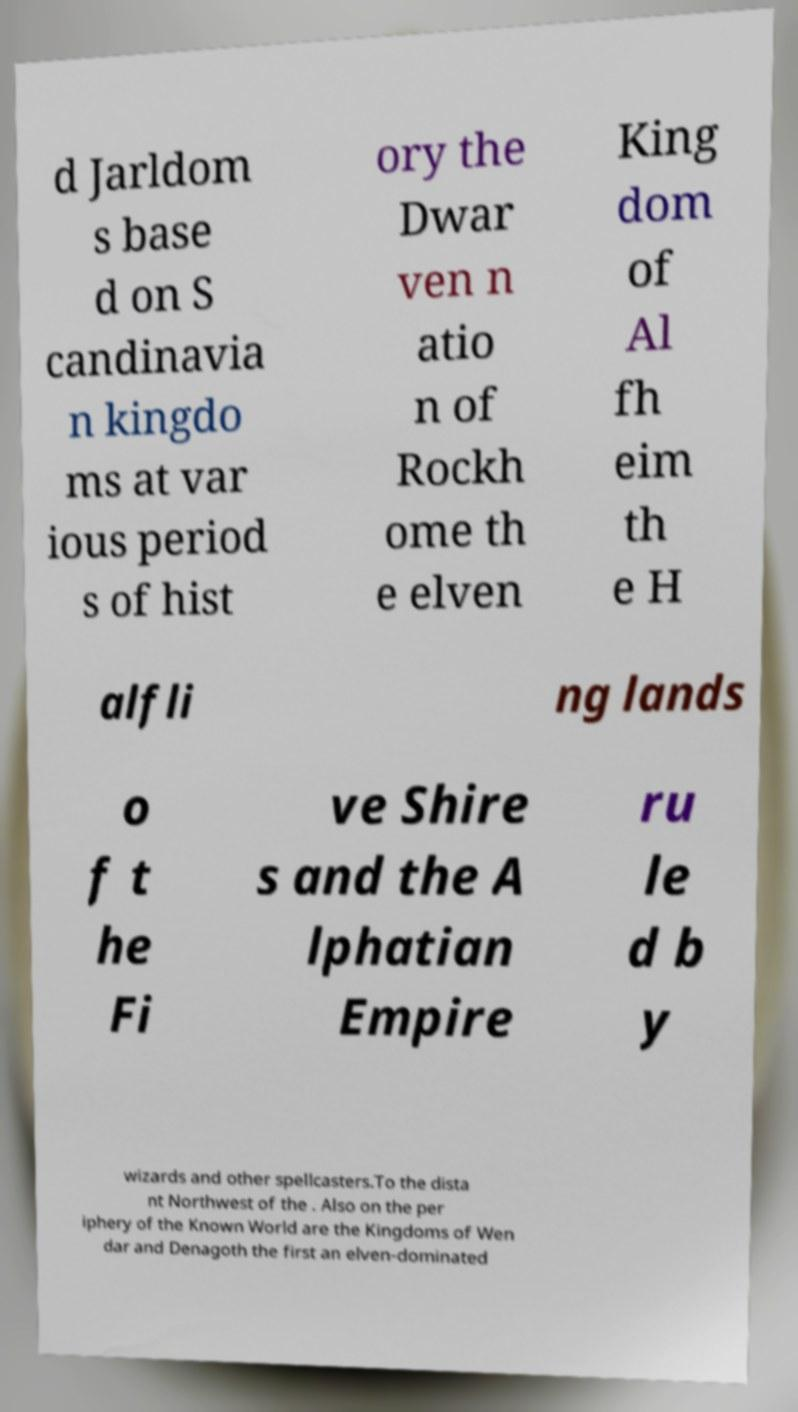For documentation purposes, I need the text within this image transcribed. Could you provide that? d Jarldom s base d on S candinavia n kingdo ms at var ious period s of hist ory the Dwar ven n atio n of Rockh ome th e elven King dom of Al fh eim th e H alfli ng lands o f t he Fi ve Shire s and the A lphatian Empire ru le d b y wizards and other spellcasters.To the dista nt Northwest of the . Also on the per iphery of the Known World are the Kingdoms of Wen dar and Denagoth the first an elven-dominated 